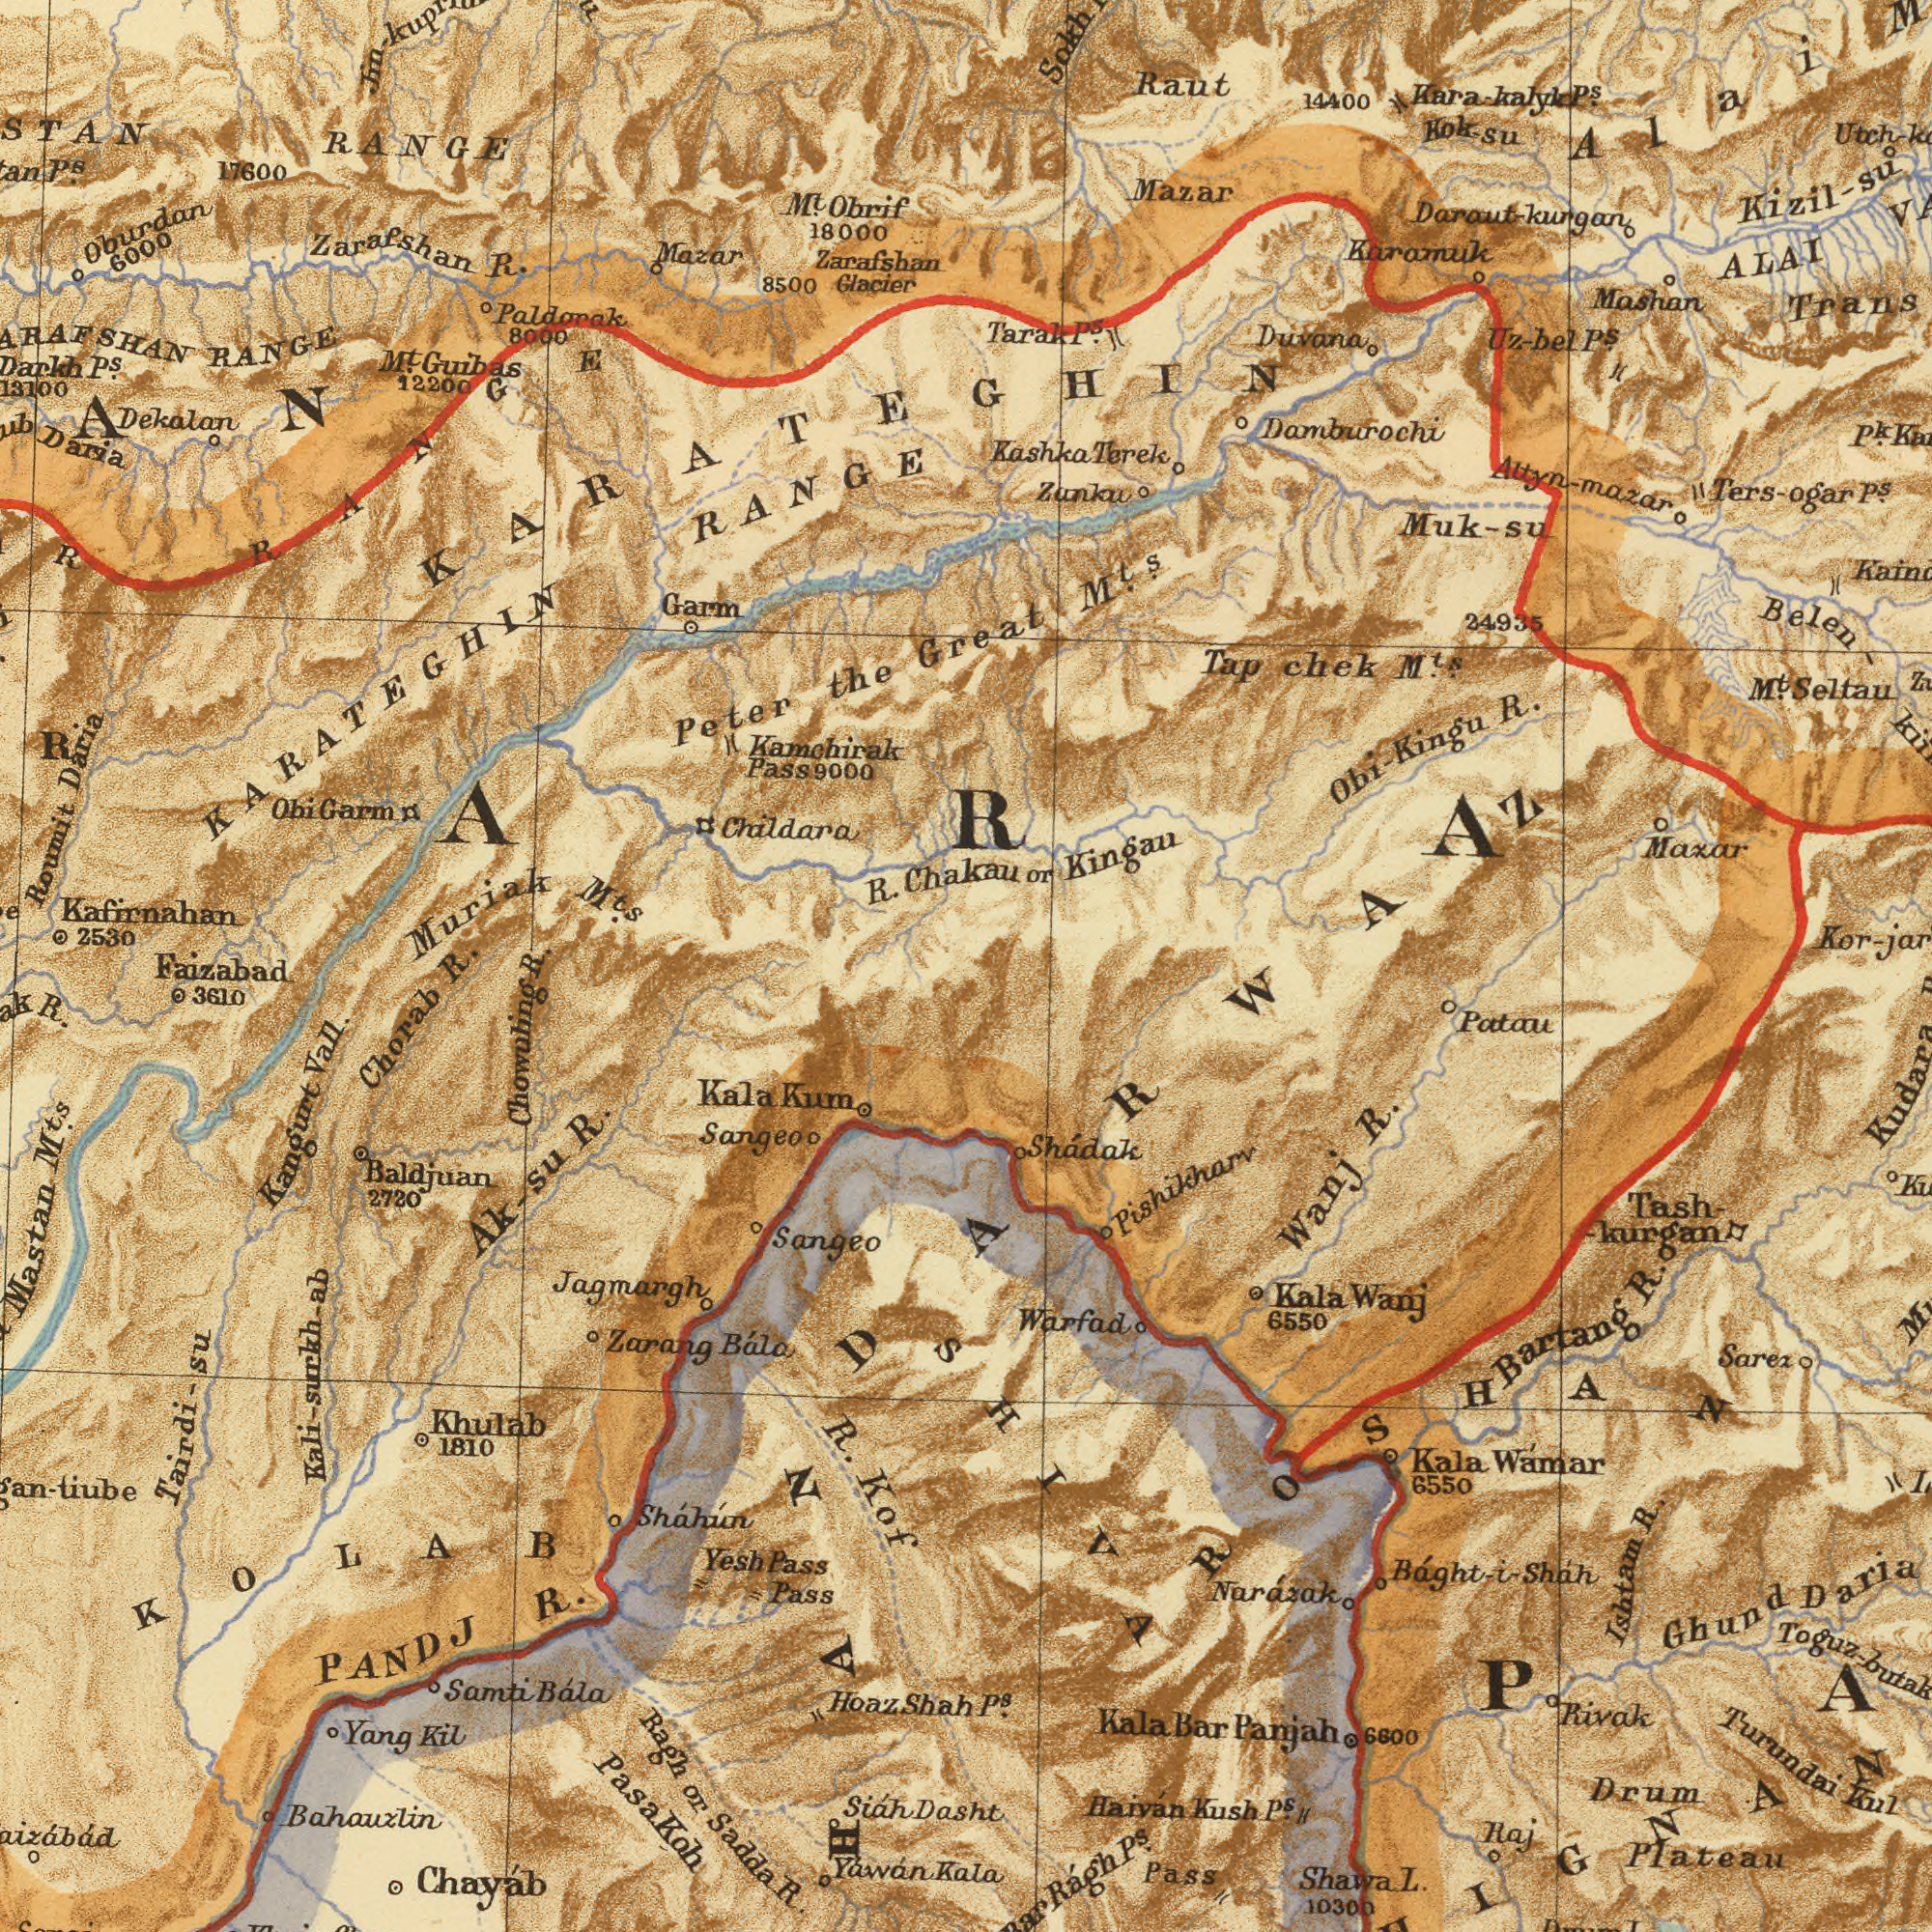What text can you see in the bottom-left section? Chowuling Bahauxlin Chayáb M<sup>ts</sup>. R. Vall. Baldjuan Sangeo R. Yáwán Chorab Mastan Sangeo Jagmargh or Pass Pass Bála Khulab 1810 Pasa Zarang Kangurt 3610 Yang Kala R. Hoaz Kil Yesh R. R. Sadda Bála PANDJ Samti Shah Sháhún Dasht 2720 Kof Siáh Kum Koh Faizabad Ragh Ak-su KOLAB Kali-surkh-ab Tairdi-su What text is visible in the lower-right corner? R. R. Turundai Plateau Drum Ishtam Pass Wámar L. Shádak Patau Ghund Wanj 6550 Daria Tash- Rivak 6550 Bartang Haiván Sarea Kul 10300 Warfad Raj Kala Kush Kala Wanj Kudara Bar Kala Pishikharv 6600 Báght-i-Sháh Panjah P<sup>s</sup>. Shawa -kurgan Rágh P<sup>s</sup>. Narázak SHIVA P<sup>s</sup>. R. Kala DARWAZ ROSHAN What text can you see in the top-left section? Muriak Kafirnahan M<sup>ts</sup>. Kamchirak RANGE Roumit Daria Paldorak Garm Daria 12200 8500 R. 18000 2530 Dekalan Childara Guibas Glacier RANGE Zarafshan the Zarafshan Oburdan R. Obrif Mazar RANGE Pass M<sup>t</sup>. 8000 17600 6000 M<sup>t</sup>. Peter Chakau P<sup>s</sup>. Garm KARATEGHIN Ohi P<sup>s</sup>. KARATEGHIN RANGE R. R. 9000 What text can you see in the top-right section? Maxar Trans Mashan ALAI Kashka Tap Mazar Altyn-mazar Sokh Raut R. Seltau Obi- Kingu Muk-su Belen- Kingau 14400 Terek Kizil-su P<sup>s</sup>. Damburochi M<sup>t</sup>. Daraut-kurgan M<sup>ts</sup>. Great 24935 Zanku or Karamuk chek P<sup>s</sup>. Tarak P<sup>s</sup>. Uz-bel M<sup>ts</sup>. P<sup>s</sup>. Ters-ogar Duvana Kara-kalyk P<sup>k</sup>. Kok-su Alai ###ARA### 